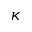<formula> <loc_0><loc_0><loc_500><loc_500>\kappa</formula> 